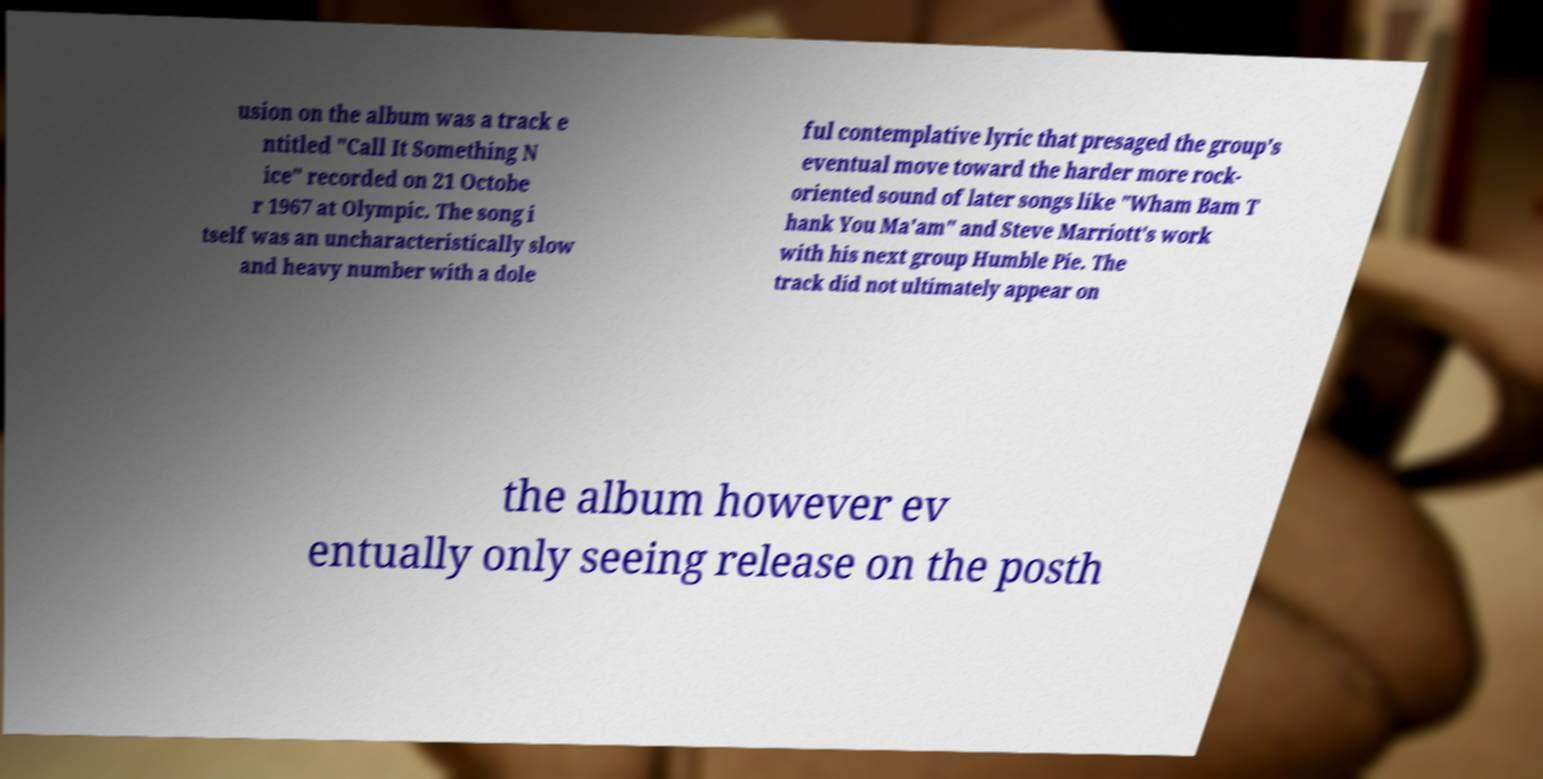Please read and relay the text visible in this image. What does it say? usion on the album was a track e ntitled "Call It Something N ice" recorded on 21 Octobe r 1967 at Olympic. The song i tself was an uncharacteristically slow and heavy number with a dole ful contemplative lyric that presaged the group's eventual move toward the harder more rock- oriented sound of later songs like "Wham Bam T hank You Ma'am" and Steve Marriott's work with his next group Humble Pie. The track did not ultimately appear on the album however ev entually only seeing release on the posth 